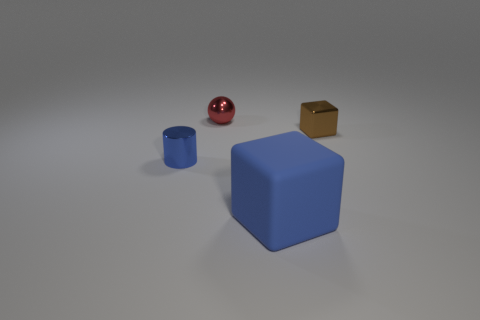Is there any other thing that is the same size as the rubber cube?
Ensure brevity in your answer.  No. There is a rubber object that is the same color as the tiny cylinder; what shape is it?
Your response must be concise. Cube. Is there anything else that has the same material as the large blue thing?
Keep it short and to the point. No. Do the blue cylinder and the red ball have the same material?
Provide a succinct answer. Yes. What is the shape of the small shiny thing in front of the tiny metal object that is to the right of the cube in front of the small cylinder?
Provide a succinct answer. Cylinder. Is the number of tiny spheres that are right of the metallic sphere less than the number of blue cubes in front of the matte thing?
Your answer should be very brief. No. What shape is the blue thing in front of the blue object behind the rubber cube?
Keep it short and to the point. Cube. Are there any other things that have the same color as the rubber block?
Keep it short and to the point. Yes. Is the tiny cube the same color as the tiny shiny cylinder?
Offer a very short reply. No. How many red things are either small matte cylinders or metal things?
Provide a short and direct response. 1. 